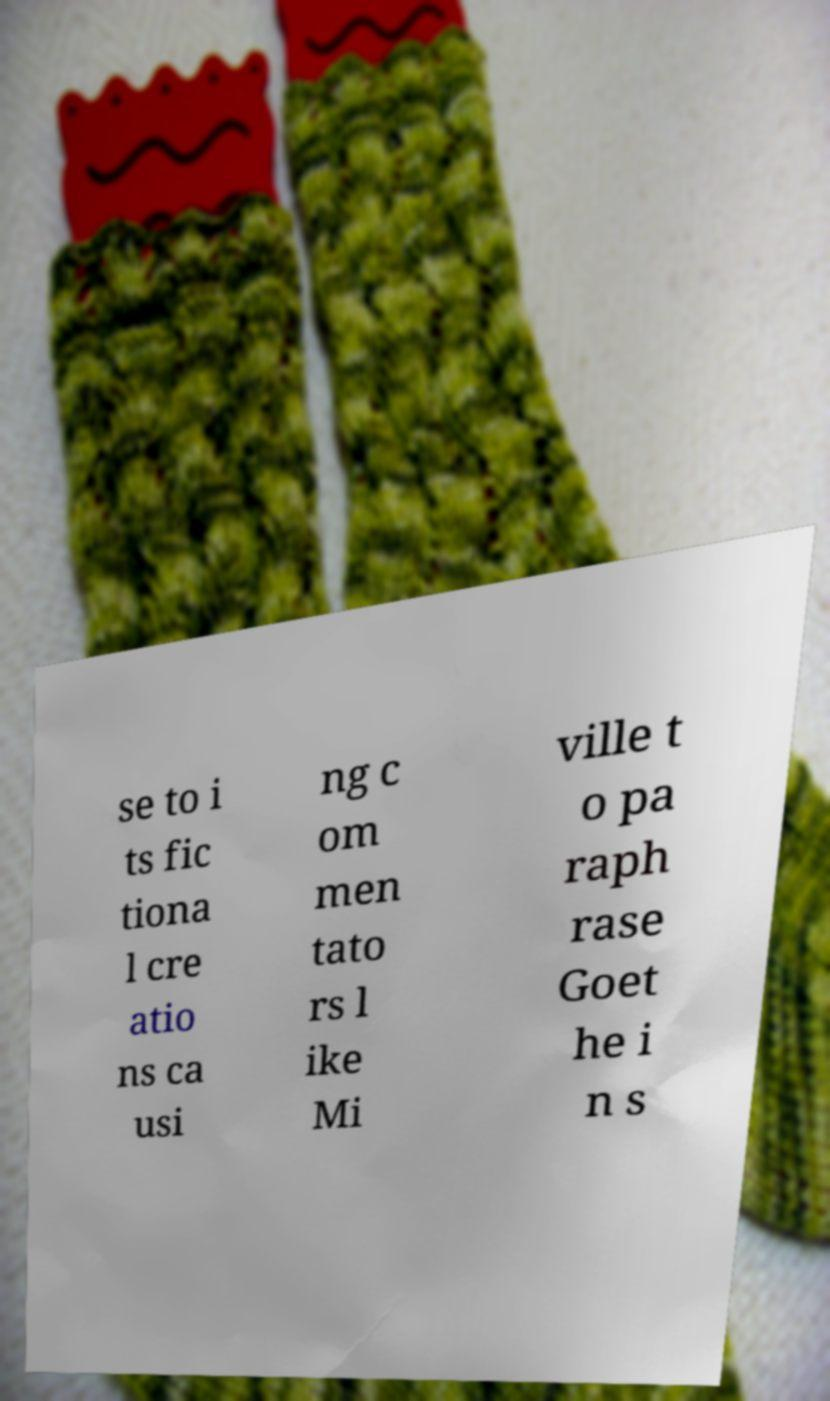Can you read and provide the text displayed in the image?This photo seems to have some interesting text. Can you extract and type it out for me? se to i ts fic tiona l cre atio ns ca usi ng c om men tato rs l ike Mi ville t o pa raph rase Goet he i n s 